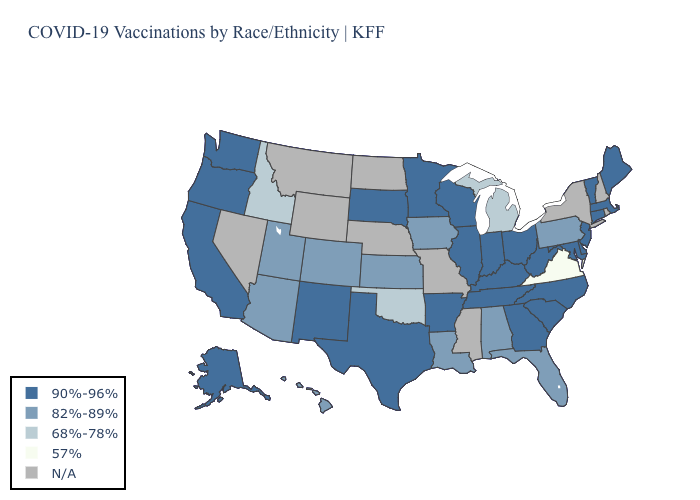Which states hav the highest value in the South?
Quick response, please. Arkansas, Delaware, Georgia, Kentucky, Maryland, North Carolina, South Carolina, Tennessee, Texas, West Virginia. Does the first symbol in the legend represent the smallest category?
Give a very brief answer. No. What is the value of Kansas?
Give a very brief answer. 82%-89%. Does the map have missing data?
Quick response, please. Yes. Which states hav the highest value in the South?
Quick response, please. Arkansas, Delaware, Georgia, Kentucky, Maryland, North Carolina, South Carolina, Tennessee, Texas, West Virginia. What is the highest value in the South ?
Be succinct. 90%-96%. Does Oregon have the lowest value in the West?
Quick response, please. No. Which states have the lowest value in the USA?
Write a very short answer. Virginia. Does Vermont have the highest value in the Northeast?
Short answer required. Yes. What is the value of West Virginia?
Concise answer only. 90%-96%. Among the states that border Oklahoma , does Arkansas have the lowest value?
Short answer required. No. Name the states that have a value in the range 90%-96%?
Write a very short answer. Alaska, Arkansas, California, Connecticut, Delaware, Georgia, Illinois, Indiana, Kentucky, Maine, Maryland, Massachusetts, Minnesota, New Jersey, New Mexico, North Carolina, Ohio, Oregon, South Carolina, South Dakota, Tennessee, Texas, Vermont, Washington, West Virginia, Wisconsin. Name the states that have a value in the range N/A?
Be succinct. Mississippi, Missouri, Montana, Nebraska, Nevada, New Hampshire, New York, North Dakota, Rhode Island, Wyoming. 